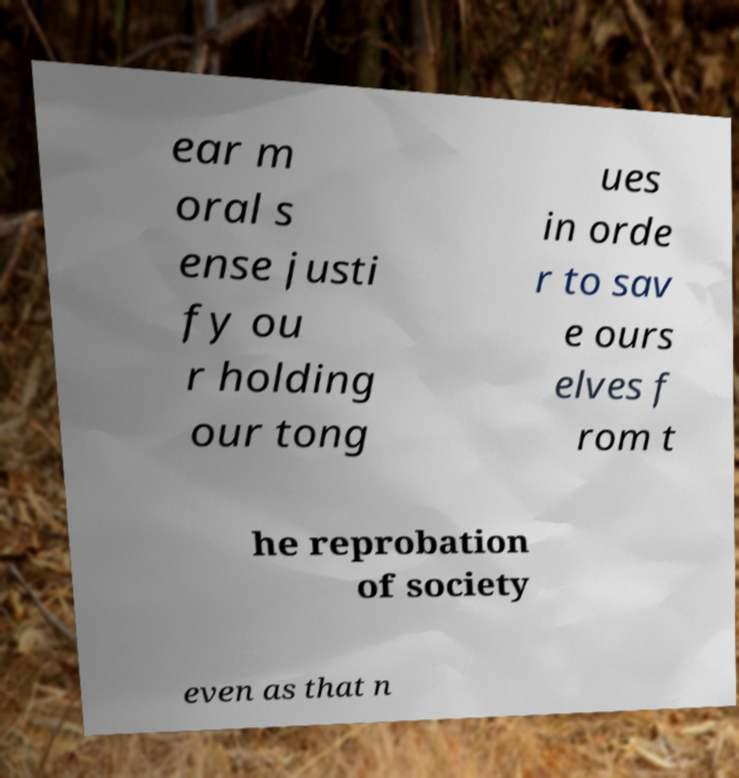For documentation purposes, I need the text within this image transcribed. Could you provide that? ear m oral s ense justi fy ou r holding our tong ues in orde r to sav e ours elves f rom t he reprobation of society even as that n 